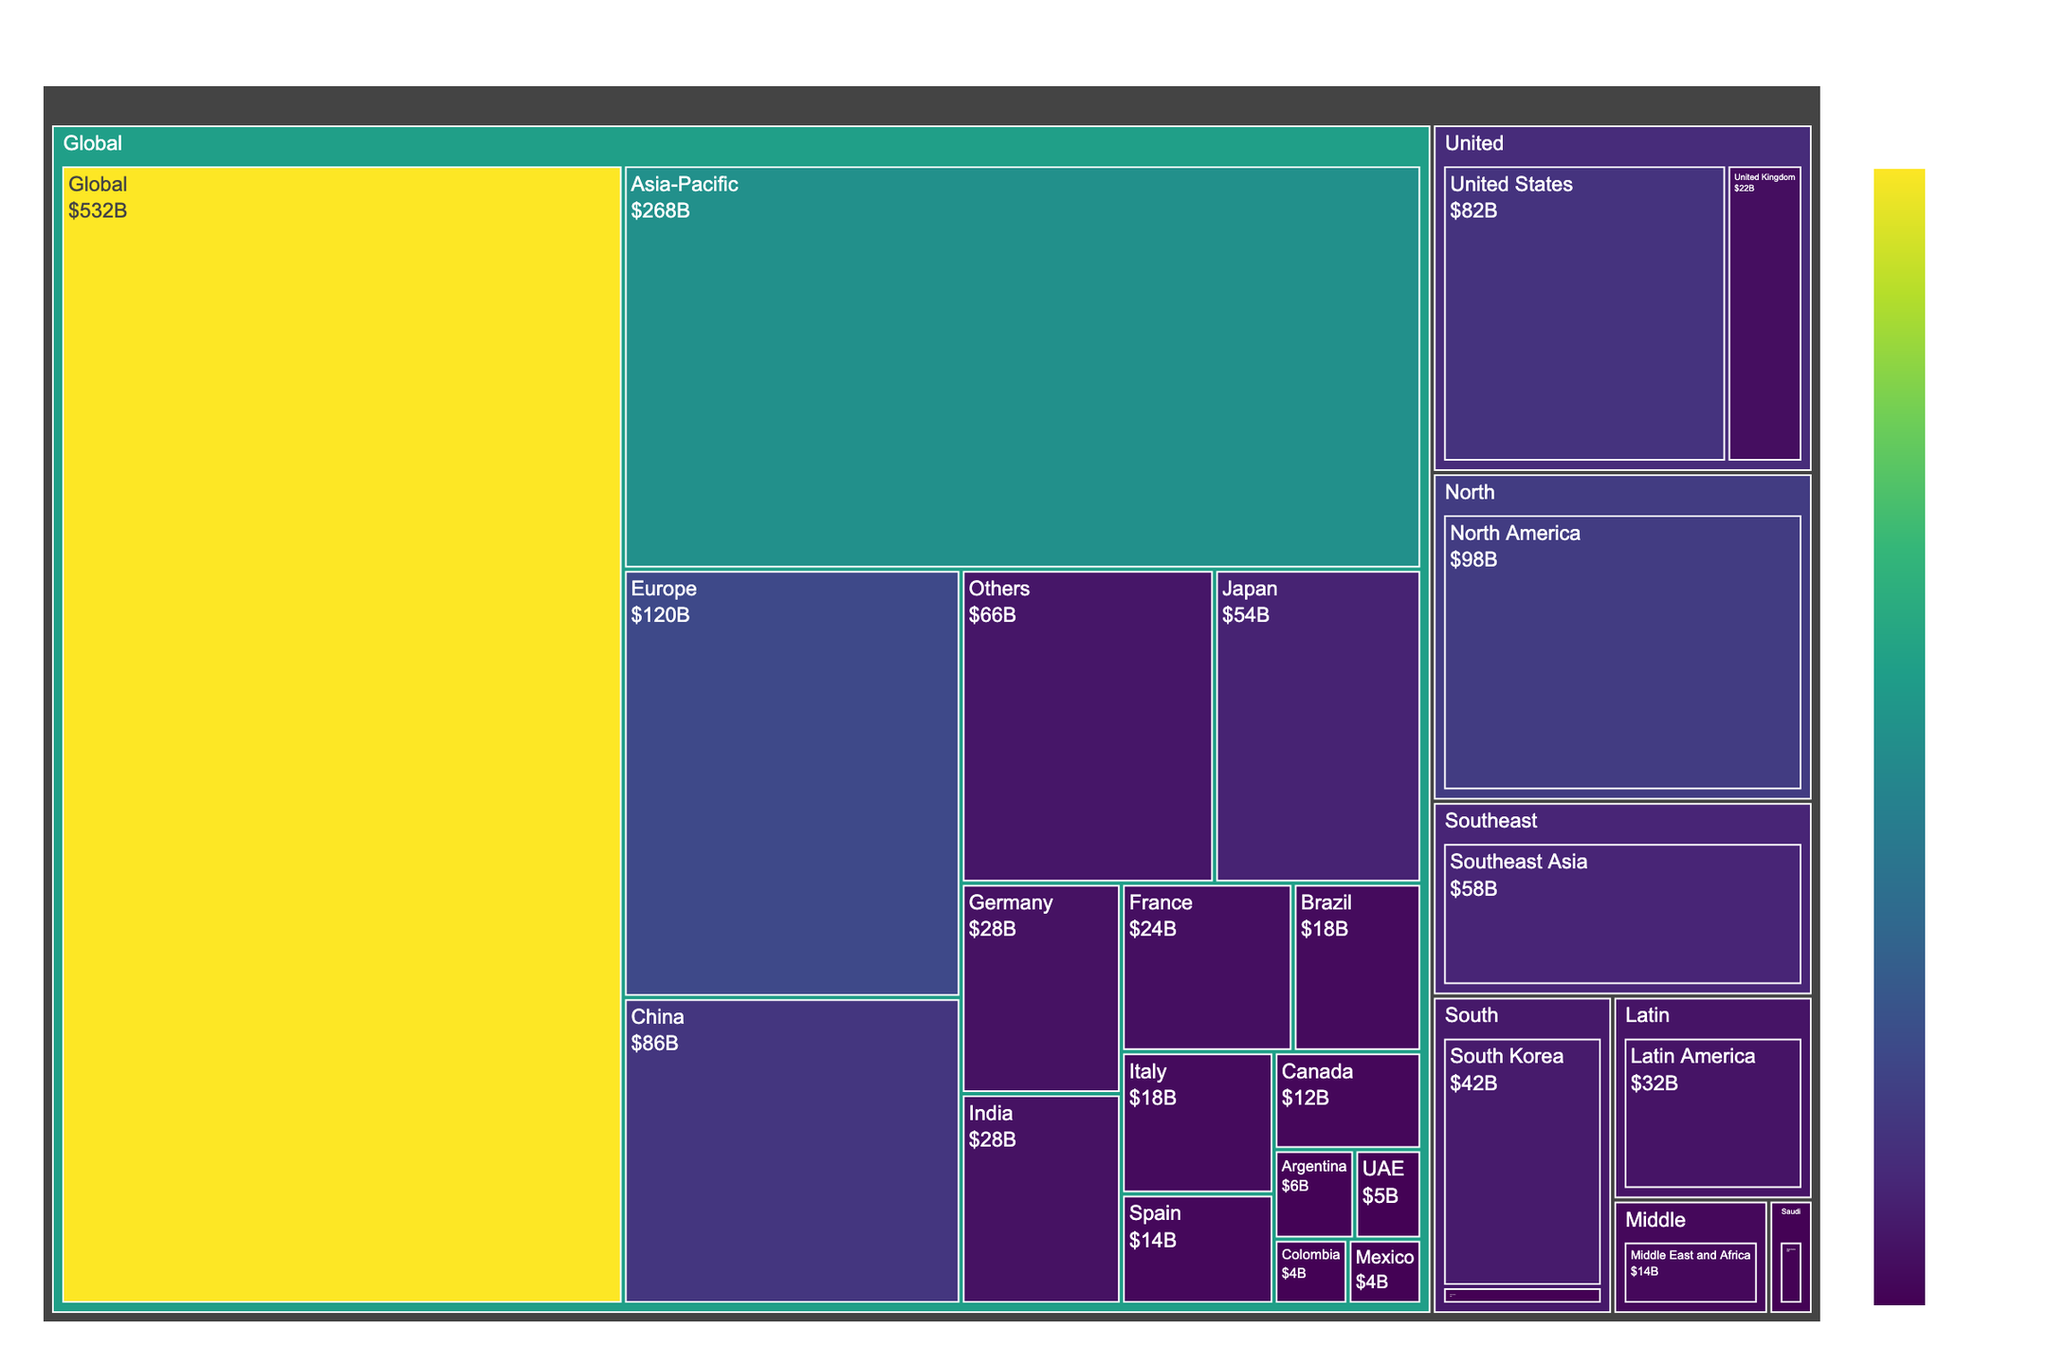What's the title of the treemap? The title is located at the top center of the treemap. It provides an overview of what the treemap represents.
Answer: Global Beauty Market Size by Region Which region has the largest market size? By looking at the size of the segments and the data labels, we can identify the largest region.
Answer: Asia-Pacific What is the market size of Europe? Find the Europe segment within the treemap and refer to the data label for the market size.
Answer: 120 Billion How does the market size of North America compare to Europe? Compare the market sizes by referring to the respective segments in the treemap. North America has a market size of 98 Billion, whereas Europe has 120 Billion, so Europe is larger.
Answer: Europe is larger What's the combined market size of China and Japan? Sum the market sizes of China and Japan by finding their individual values from the Asia-Pacific region. China is 86 Billion and Japan is 54 Billion; combined, they are 140 Billion.
Answer: 140 Billion Which country in Latin America has the highest market size? Within the Latin America segment, compare the market sizes of Brazil, Argentina, Colombia, and Others. Brazil has the largest market size.
Answer: Brazil How does the market size of South Korea compare to India? Both are under the Asia-Pacific region. Compare their market sizes: South Korea is 42 Billion, and India is 28 Billion. South Korea has a larger market size.
Answer: South Korea is larger What is the total market size of the Middle East and Africa? The total can be viewed directly from the Middle East and Africa segment's value.
Answer: 14 Billion What's the difference in market size between United States and Canada? Subtract Canada’s market size from that of the United States: 82 Billion (United States) - 12 Billion (Canada) = 70 Billion.
Answer: 70 Billion What is the average market size of the top five countries in Europe? Identify the five countries in Europe (Germany, France, United Kingdom, Italy, Spain), sum their market sizes and divide by 5: (28 + 24 + 22 + 18 + 14)/5 = 21.2 Billion.
Answer: 21.2 Billion 